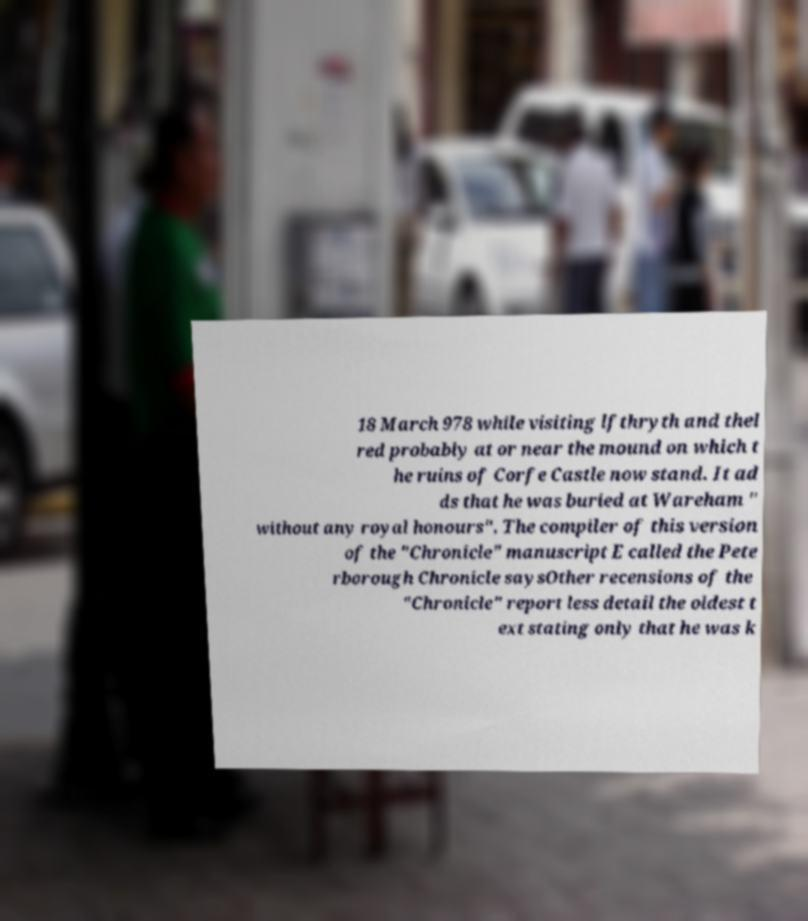I need the written content from this picture converted into text. Can you do that? 18 March 978 while visiting lfthryth and thel red probably at or near the mound on which t he ruins of Corfe Castle now stand. It ad ds that he was buried at Wareham " without any royal honours". The compiler of this version of the "Chronicle" manuscript E called the Pete rborough Chronicle saysOther recensions of the "Chronicle" report less detail the oldest t ext stating only that he was k 